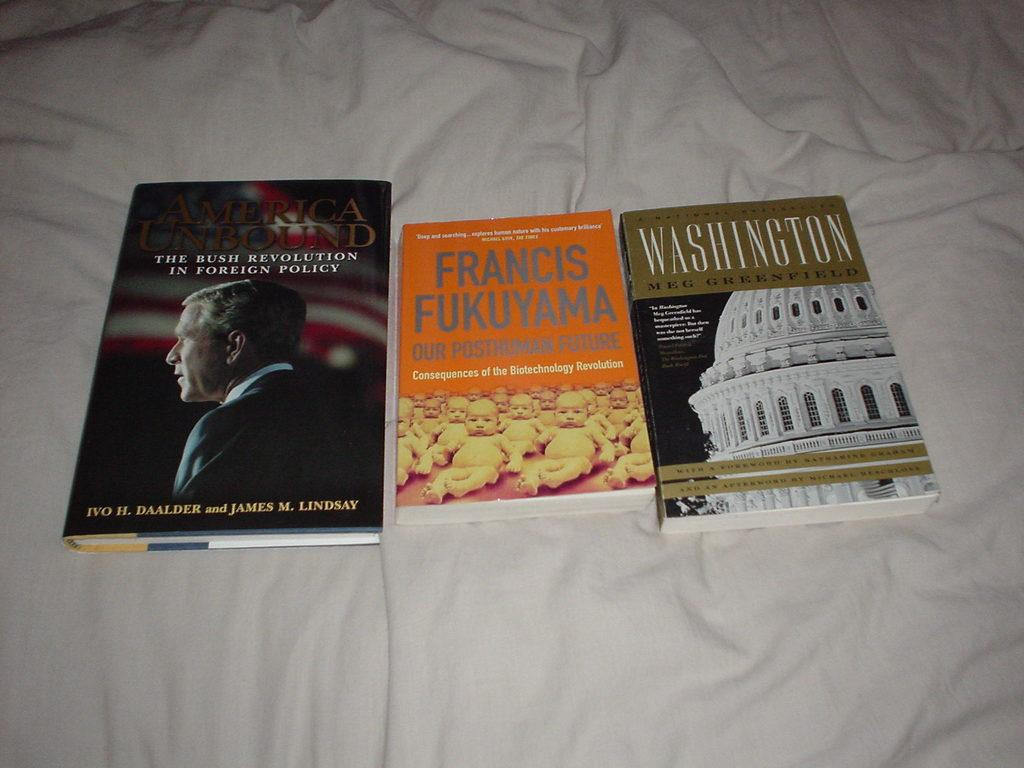<image>
Relay a brief, clear account of the picture shown. Three books are on a blanket including American Unbound. 